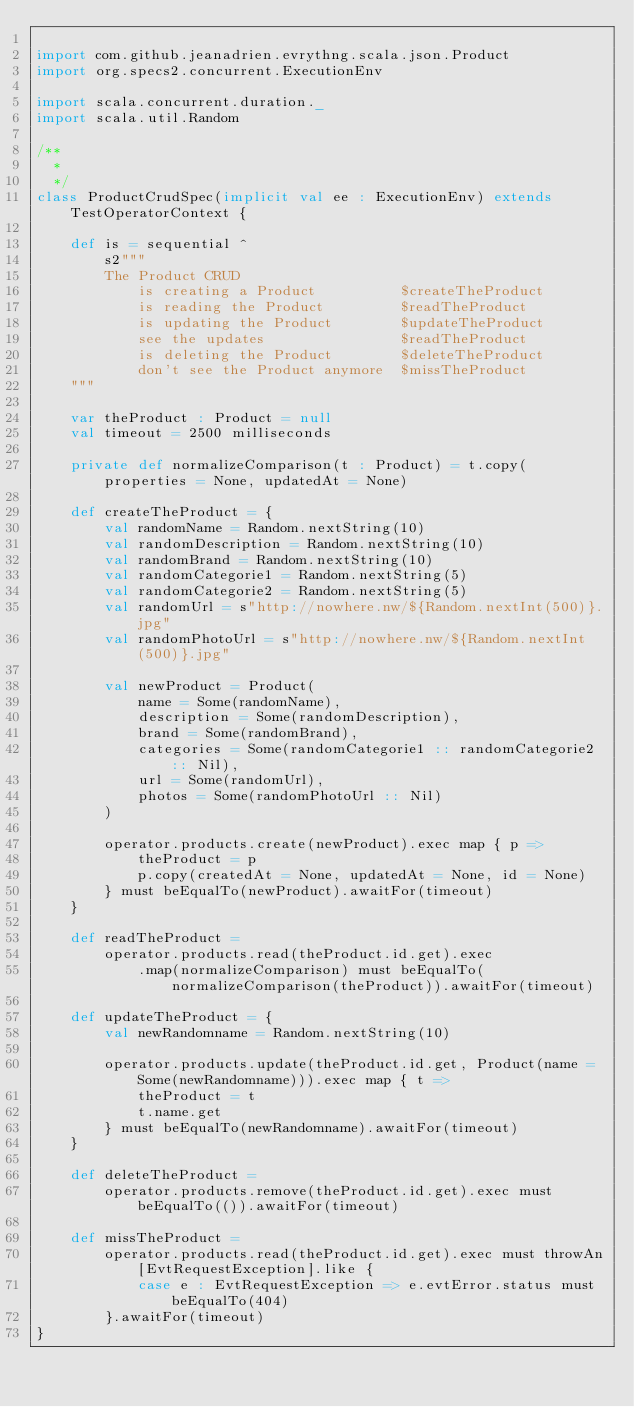Convert code to text. <code><loc_0><loc_0><loc_500><loc_500><_Scala_>
import com.github.jeanadrien.evrythng.scala.json.Product
import org.specs2.concurrent.ExecutionEnv

import scala.concurrent.duration._
import scala.util.Random

/**
  *
  */
class ProductCrudSpec(implicit val ee : ExecutionEnv) extends TestOperatorContext {

    def is = sequential ^
        s2"""
        The Product CRUD
            is creating a Product          $createTheProduct
            is reading the Product         $readTheProduct
            is updating the Product        $updateTheProduct
            see the updates                $readTheProduct
            is deleting the Product        $deleteTheProduct
            don't see the Product anymore  $missTheProduct
    """

    var theProduct : Product = null
    val timeout = 2500 milliseconds

    private def normalizeComparison(t : Product) = t.copy(properties = None, updatedAt = None)

    def createTheProduct = {
        val randomName = Random.nextString(10)
        val randomDescription = Random.nextString(10)
        val randomBrand = Random.nextString(10)
        val randomCategorie1 = Random.nextString(5)
        val randomCategorie2 = Random.nextString(5)
        val randomUrl = s"http://nowhere.nw/${Random.nextInt(500)}.jpg"
        val randomPhotoUrl = s"http://nowhere.nw/${Random.nextInt(500)}.jpg"

        val newProduct = Product(
            name = Some(randomName),
            description = Some(randomDescription),
            brand = Some(randomBrand),
            categories = Some(randomCategorie1 :: randomCategorie2 :: Nil),
            url = Some(randomUrl),
            photos = Some(randomPhotoUrl :: Nil)
        )

        operator.products.create(newProduct).exec map { p =>
            theProduct = p
            p.copy(createdAt = None, updatedAt = None, id = None)
        } must beEqualTo(newProduct).awaitFor(timeout)
    }

    def readTheProduct =
        operator.products.read(theProduct.id.get).exec
            .map(normalizeComparison) must beEqualTo(normalizeComparison(theProduct)).awaitFor(timeout)

    def updateTheProduct = {
        val newRandomname = Random.nextString(10)

        operator.products.update(theProduct.id.get, Product(name = Some(newRandomname))).exec map { t =>
            theProduct = t
            t.name.get
        } must beEqualTo(newRandomname).awaitFor(timeout)
    }

    def deleteTheProduct =
        operator.products.remove(theProduct.id.get).exec must beEqualTo(()).awaitFor(timeout)

    def missTheProduct =
        operator.products.read(theProduct.id.get).exec must throwAn[EvtRequestException].like {
            case e : EvtRequestException => e.evtError.status must beEqualTo(404)
        }.awaitFor(timeout)
}
</code> 